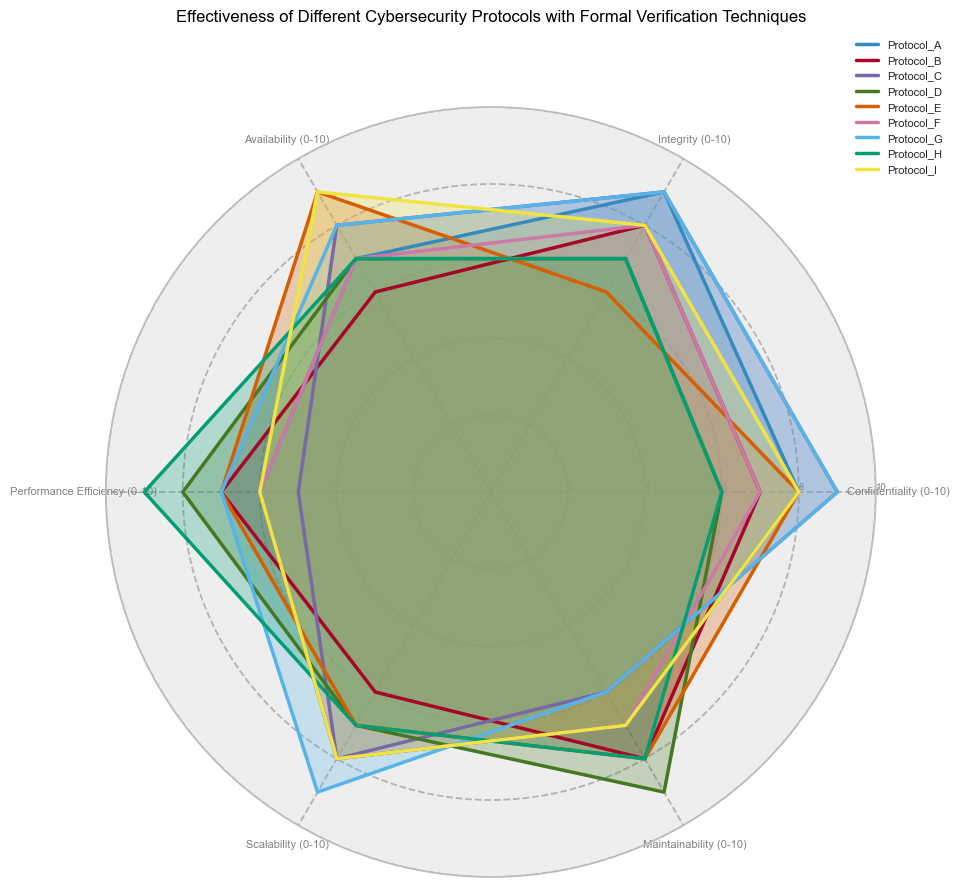What's the protocol with the highest confidentiality rating? To find the protocol with the highest confidentiality rating, we look for the maximum point on the "Confidentiality" axis. Protocols with a rating of 9 in Confidentiality are Protocol_C and Protocol_G. Both these protocols share the highest confidentiality rating.
Answer: Protocol_C and Protocol_G Which protocol has the lowest integrity rating? To determine which protocol has the lowest integrity rating, we locate the point on the "Integrity" axis that is closest to the center (0). Protocol_E has the lowest integrity rating of 6.
Answer: Protocol_E Compare the performance efficiency of Protocol_D and Protocol_H. Which one performs better? We need to compare the "Performance Efficiency" scores of Protocol_D and Protocol_H. Protocol_D has a performance efficiency of 8, while Protocol_H has a higher performance efficiency of 9. Thus, Protocol_H performs better.
Answer: Protocol_H What is the average maintainability score across all protocols? To find the average maintainability score, sum up all the maintainability values from each protocol: (7 + 8 + 6 + 9 + 8 + 7 + 6 + 8 + 7) = 66. Then, divide the sum by the number of protocols (9): 66/9.
Answer: 7.33 Which protocol has the highest aggregate score across all categories? To determine the protocol with the highest aggregate score, sum up the values for all categories for each protocol and compare them. Protocol_G has an aggregate score of (9 + 9 + 8 + 7 + 9 + 6) = 48, which is the highest.
Answer: Protocol_G Identify the protocols that have equal or higher availability than their confidentiality ratings. For this, compare the "Availability" rating to the "Confidentiality" rating for each protocol. Only Protocol_I has an availability (9) that is higher than its confidentiality (8). Protocols with equal or higher availability than confidentiality are: **Protocol_I**.
Answer: Protocol_I What's the difference in scalability between Protocol_B and Protocol_E? To find the difference in scalability between Protocol_B (scalability of 6) and Protocol_E (scalability of 7), subtract the smaller value from the larger one: 7 - 6.
Answer: 1 Compare the range of integrity values across all protocols. To find the range of integrity values, identify the maximum and minimum integrity ratings. The highest is 9 (Protocol_A, Protocol_C, Protocol_G) and the lowest is 6 (Protocol_E). Calculate the difference: 9 - 6.
Answer: 3 